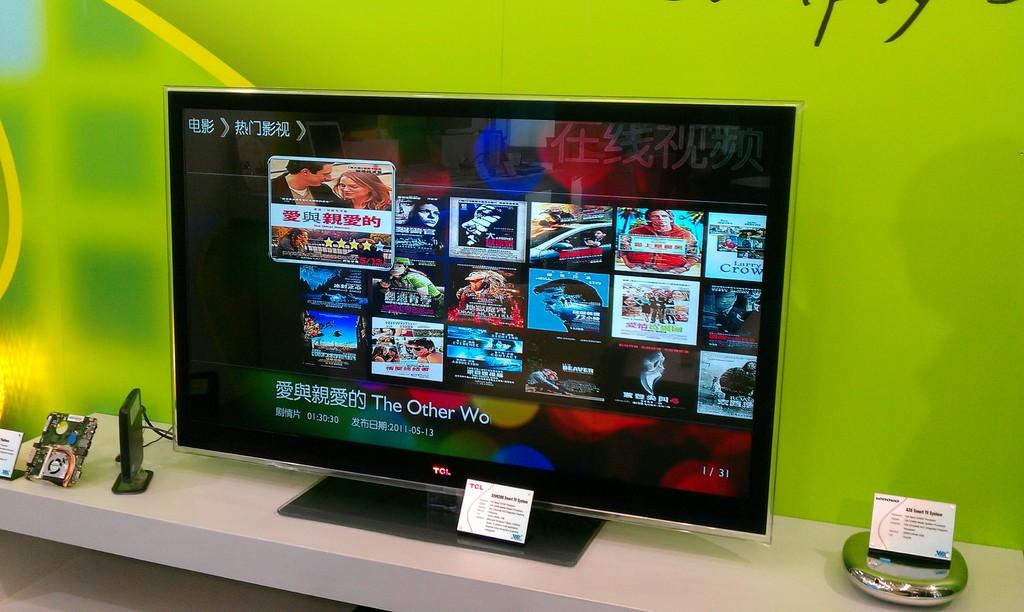What is the title of the television show?
Make the answer very short. The other wo. What brand tv?
Offer a terse response. Unanswerable. 